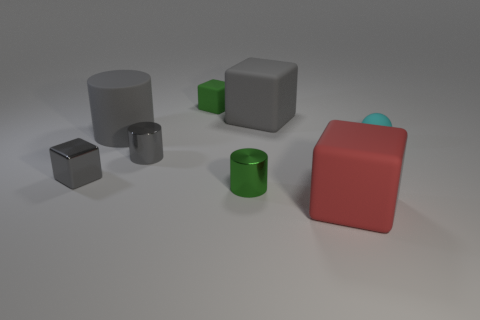Add 2 large yellow matte blocks. How many objects exist? 10 Subtract all balls. How many objects are left? 7 Subtract 0 yellow cubes. How many objects are left? 8 Subtract all small gray shiny cylinders. Subtract all big gray matte objects. How many objects are left? 5 Add 5 shiny cylinders. How many shiny cylinders are left? 7 Add 6 purple balls. How many purple balls exist? 6 